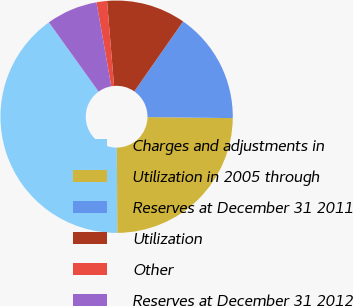<chart> <loc_0><loc_0><loc_500><loc_500><pie_chart><fcel>Charges and adjustments in<fcel>Utilization in 2005 through<fcel>Reserves at December 31 2011<fcel>Utilization<fcel>Other<fcel>Reserves at December 31 2012<nl><fcel>40.2%<fcel>24.71%<fcel>15.5%<fcel>11.01%<fcel>1.46%<fcel>7.13%<nl></chart> 